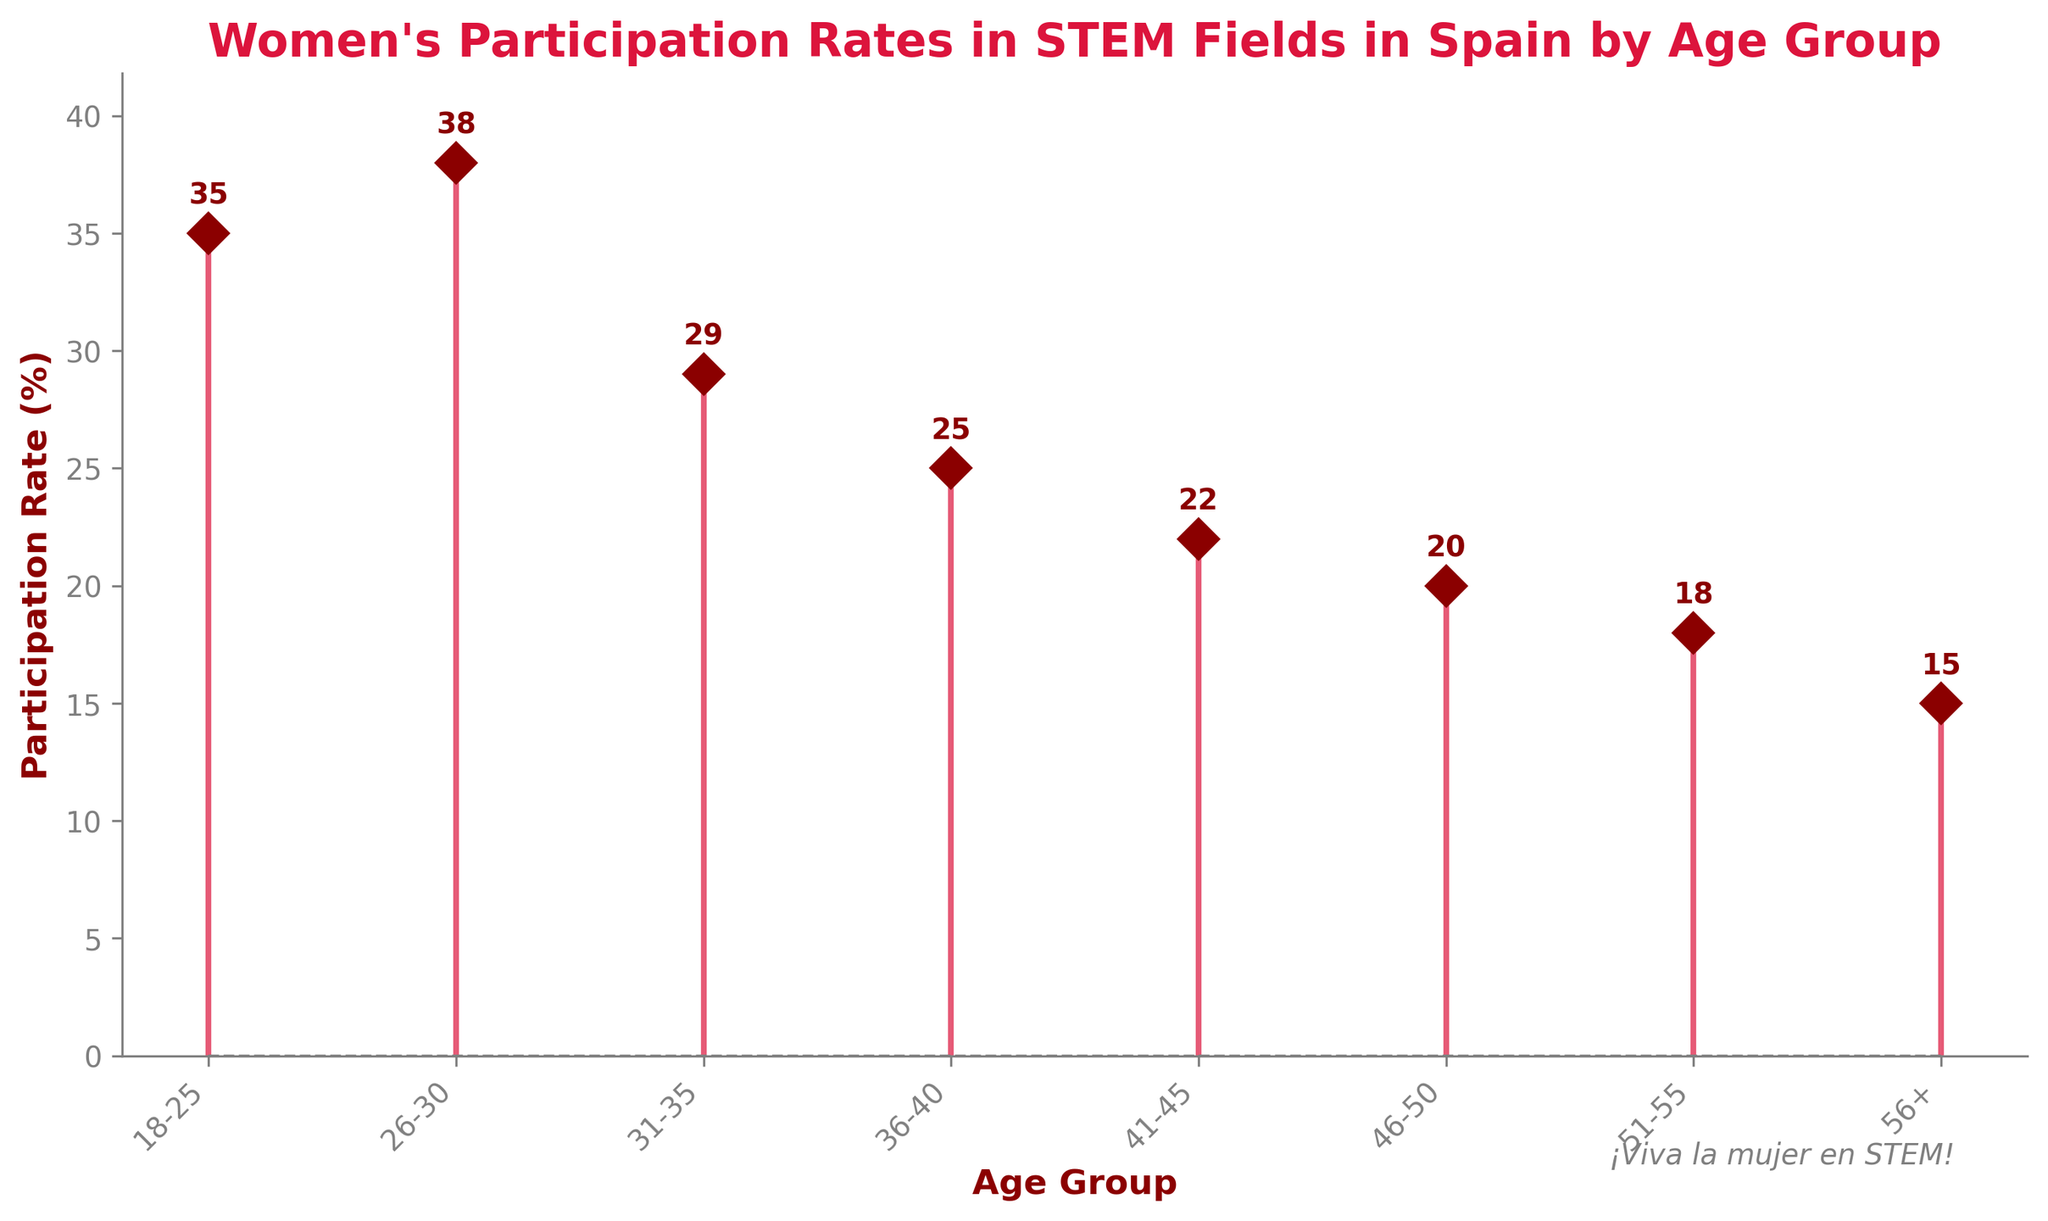What is the title of the plot? The title is clearly labeled at the top of the plot.
Answer: Women's Participation Rates in STEM Fields in Spain by Age Group What color are the lines in the plot? The lines are visibly shown in crimson color in the plot.
Answer: Crimson What is the participation rate for women aged 36-40? Find the stem corresponding to the 36-40 age group and read the participation rate from the plot.
Answer: 25% Which age group has the highest participation rate in STEM fields? Look for the age group with the tallest stem in the plot.
Answer: 26-30 How many age groups are represented in the plot? Count the number of stems or the number of labels on the x-axis.
Answer: 8 What is the difference in participation rates between the age group 18-25 and 56+? Subtract the participation rate of the 56+ age group from that of the 18-25 age group. 35% - 15% = 20%
Answer: 20% Which age groups have participation rates lower than 20%? Identify the age groups with stems that do not reach the 20% line.
Answer: 51-55, 56+ What is the participation rate trend as the age groups increase from 18-25 to 56+? Observe the pattern of the stems from left to right. Notice that the heights decrease.
Answer: Decreasing If you average the participation rates for all age groups, what is the result? Sum all the participation rates (35 + 38 + 29 + 25 + 22 + 20 + 18 + 15 = 202) and then divide by the number of age groups (8). So, 202/8 = 25.25%
Answer: 25.25% Which age group has the closest participation rate to the average rate? The calculated average rate is 25.25%. Compare this value to each age group's participation rate: 18-25 (35%), 26-30 (38%), 31-35 (29%), 36-40 (25%), 41-45 (22%), 46-50 (20%), 51-55 (18%), 56+ (15%). The age group 36-40 has 25%, which is the closest to 25.25%.
Answer: 36-40 